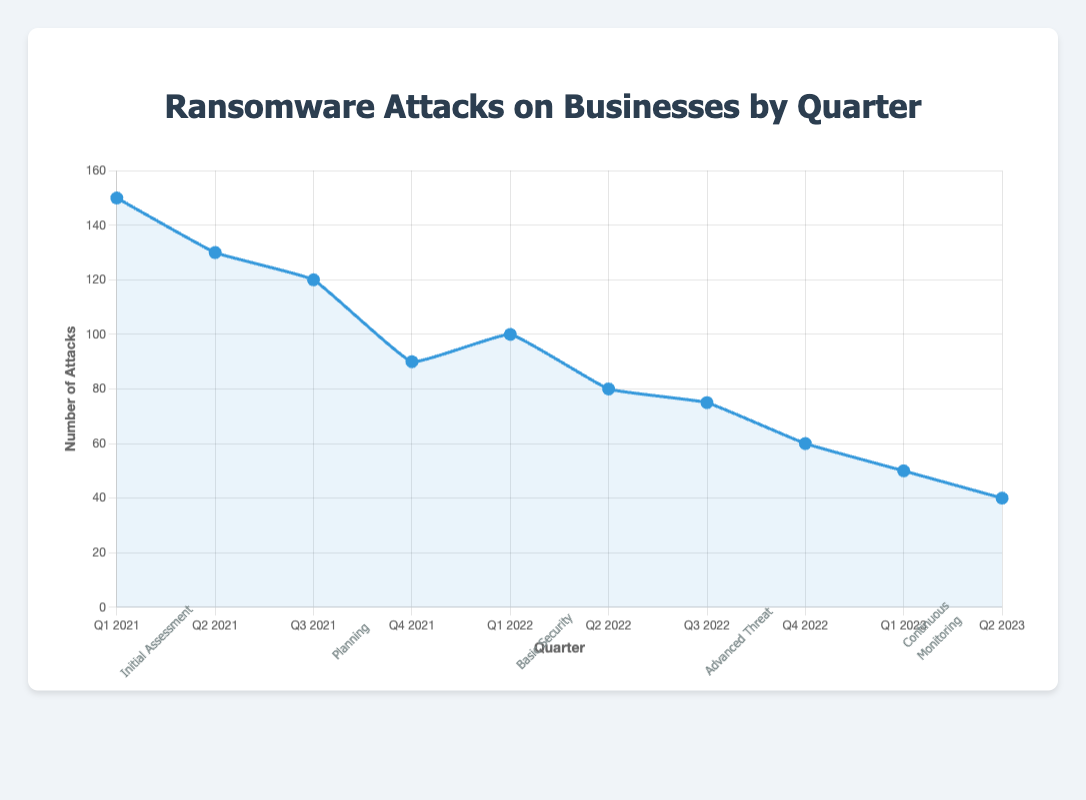What is the trend in the number of ransomware attacks from Q1 2021 to Q2 2023? The number of ransomware attacks shows a consistent decline from 150 in Q1 2021 to 40 in Q2 2023, indicating the overall effectiveness of the implemented security measures.
Answer: The trend is a consistent decline What phase of security enhancement was implemented when ransomware attacks dropped to 60? To find this, locate Q4 2022 on the chart, where the number of ransomware attacks is 60. The corresponding phase for this quarter is "Advanced Threat Detection."
Answer: Advanced Threat Detection How many attacks occurred on average during the "Initial Assessment and Inventory" phase? The "Initial Assessment and Inventory" phase covers Q1 2021 and Q2 2021 with 150 and 130 attacks respectively. The average is (150 + 130) / 2.
Answer: 140 Which quarter witnessed the sharpest decrease in ransomware attacks? Compare the differences between consecutive quarters. The sharpest decrease is from Q3 2021 to Q4 2021, reducing from 120 to 90 attacks.
Answer: Q3 2021 to Q4 2021 Compare the ransomware attacks in Q4 2021 with Q2 2022. Were there more or fewer attacks in Q4 2021? Comparing the two quarters, Q4 2021 had 90 attacks, and Q2 2022 had 80 attacks. Hence, Q4 2021 had more attacks.
Answer: More in Q4 2021 What was the difference in the number of attacks between the "Planning and Strategy Development" and "Advanced Threat Detection" phases? Summing up attacks during each phase: 120 + 90 for "Planning and Strategy Development" = 210, and 75 + 60 for "Advanced Threat Detection" = 135. The difference is 210 - 135.
Answer: 75 What visual feature helps distinguish different security enhancement phases on the chart? The chart includes phase indicators below the x-axis, clearly marked with different phase names and rotational text orientation for better visibility.
Answer: Phase indicators What is the median number of ransomware attacks over all quarters shown? Arrange the attack values in ascending order: 40, 50, 60, 75, 80, 90, 100, 120, 130, 150. With 10 values, the median is the average of the 5th and 6th values, (80 + 90) / 2.
Answer: 85 